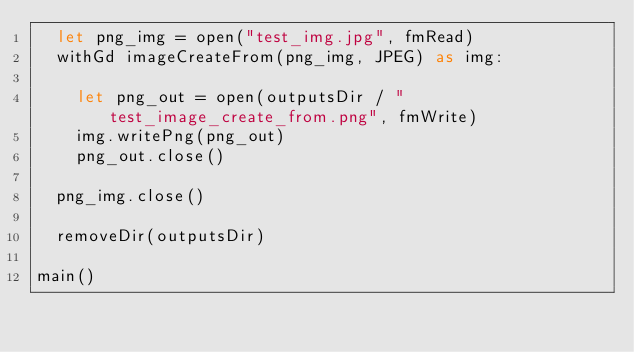Convert code to text. <code><loc_0><loc_0><loc_500><loc_500><_Nim_>  let png_img = open("test_img.jpg", fmRead)
  withGd imageCreateFrom(png_img, JPEG) as img:

    let png_out = open(outputsDir / "test_image_create_from.png", fmWrite)
    img.writePng(png_out)
    png_out.close()

  png_img.close()

  removeDir(outputsDir)

main()
</code> 